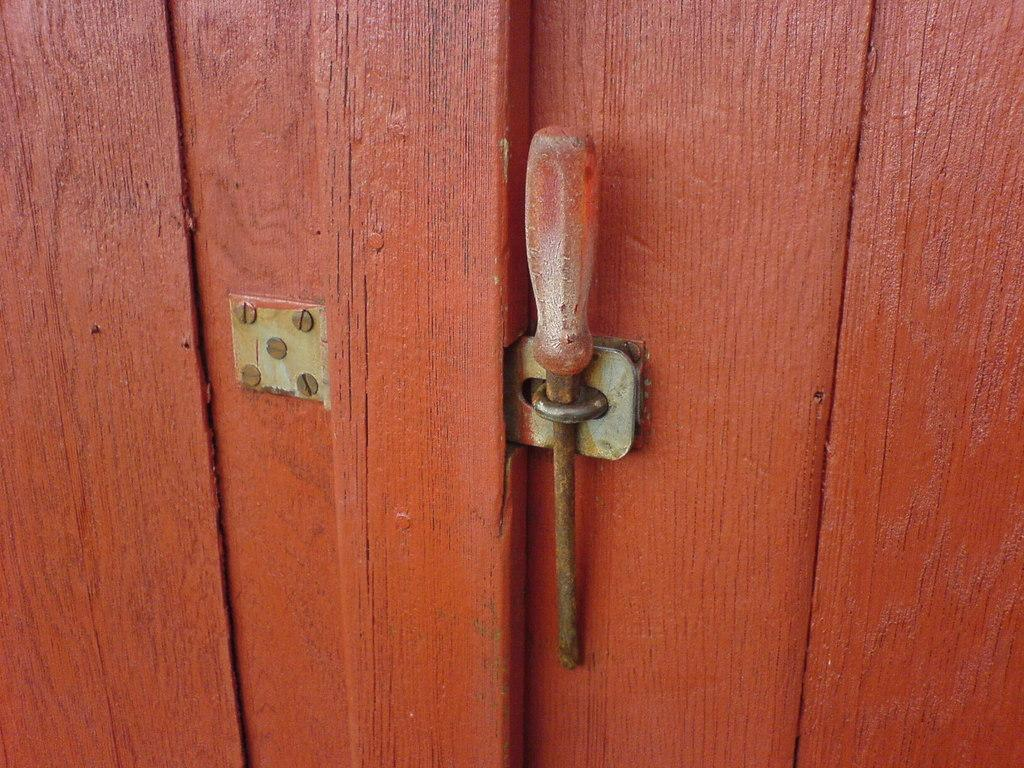What can be seen in the image related to an entryway? There is a door in the image. What is the status of the door in the image? The door is locked. What tool is used to lock the door in the image? A screwdriver is used to lock the door. What type of mitten is hanging on the door in the image? There is no mitten present in the image; the door is locked using a screwdriver. 